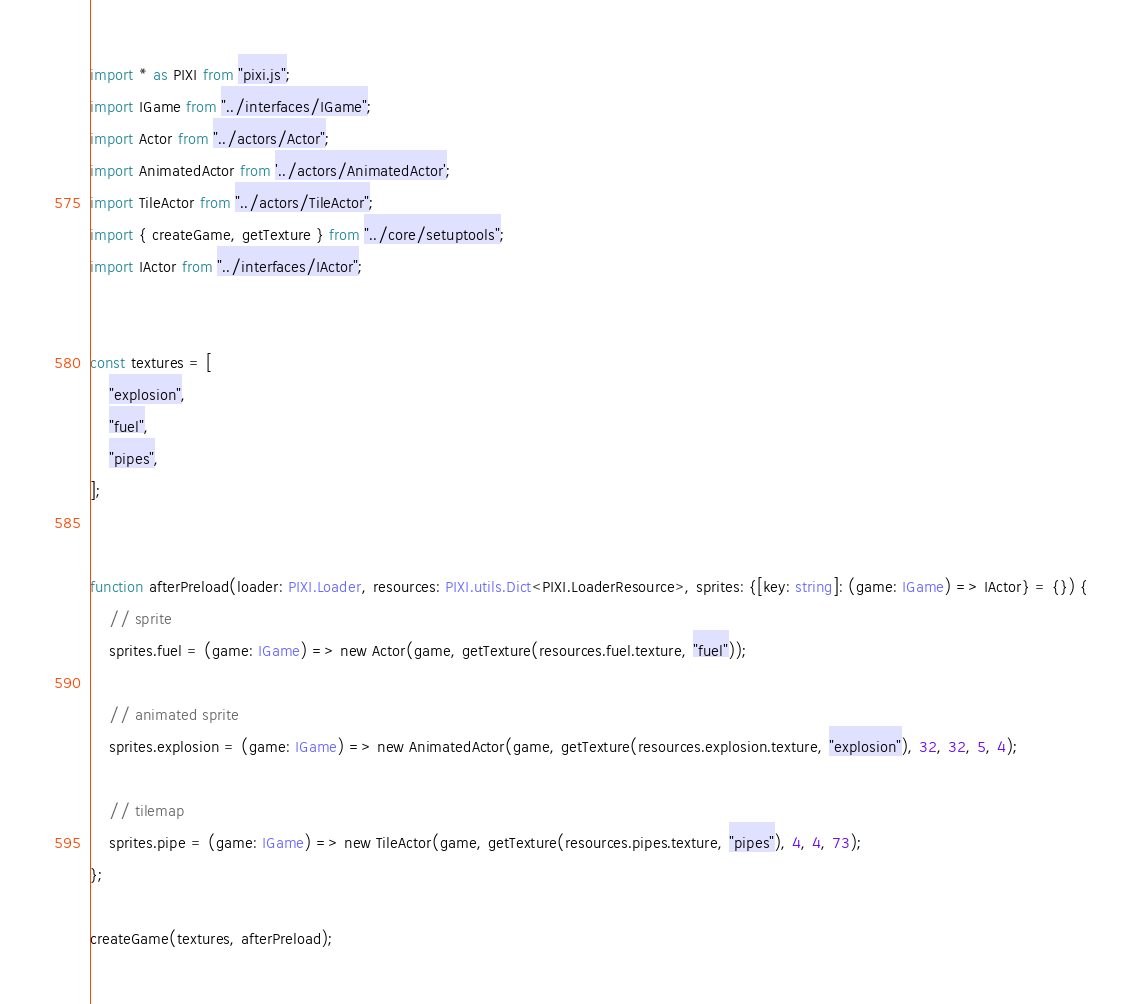Convert code to text. <code><loc_0><loc_0><loc_500><loc_500><_TypeScript_>
import * as PIXI from "pixi.js";
import IGame from "../interfaces/IGame";
import Actor from "../actors/Actor";
import AnimatedActor from '../actors/AnimatedActor';
import TileActor from "../actors/TileActor";
import { createGame, getTexture } from "../core/setuptools";
import IActor from "../interfaces/IActor";


const textures = [
    "explosion",
    "fuel",
    "pipes",
];


function afterPreload(loader: PIXI.Loader, resources: PIXI.utils.Dict<PIXI.LoaderResource>, sprites: {[key: string]: (game: IGame) => IActor} = {}) {
    // sprite
    sprites.fuel = (game: IGame) => new Actor(game, getTexture(resources.fuel.texture, "fuel"));

    // animated sprite
    sprites.explosion = (game: IGame) => new AnimatedActor(game, getTexture(resources.explosion.texture, "explosion"), 32, 32, 5, 4);

    // tilemap
    sprites.pipe = (game: IGame) => new TileActor(game, getTexture(resources.pipes.texture, "pipes"), 4, 4, 73);
};

createGame(textures, afterPreload);</code> 